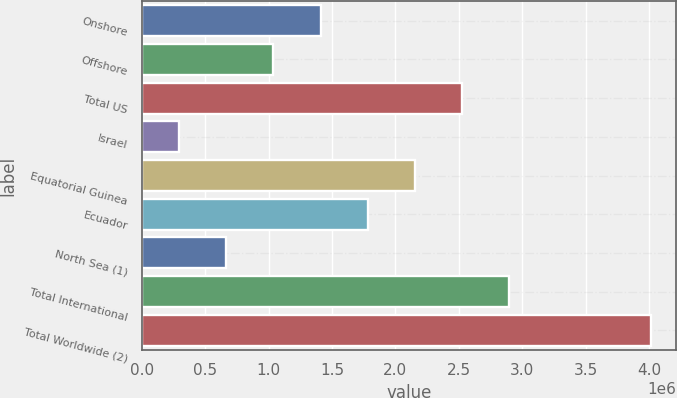<chart> <loc_0><loc_0><loc_500><loc_500><bar_chart><fcel>Onshore<fcel>Offshore<fcel>Total US<fcel>Israel<fcel>Equatorial Guinea<fcel>Ecuador<fcel>North Sea (1)<fcel>Total International<fcel>Total Worldwide (2)<nl><fcel>1.40973e+06<fcel>1.03734e+06<fcel>2.52689e+06<fcel>292572<fcel>2.1545e+06<fcel>1.78212e+06<fcel>664958<fcel>2.89928e+06<fcel>4.01644e+06<nl></chart> 